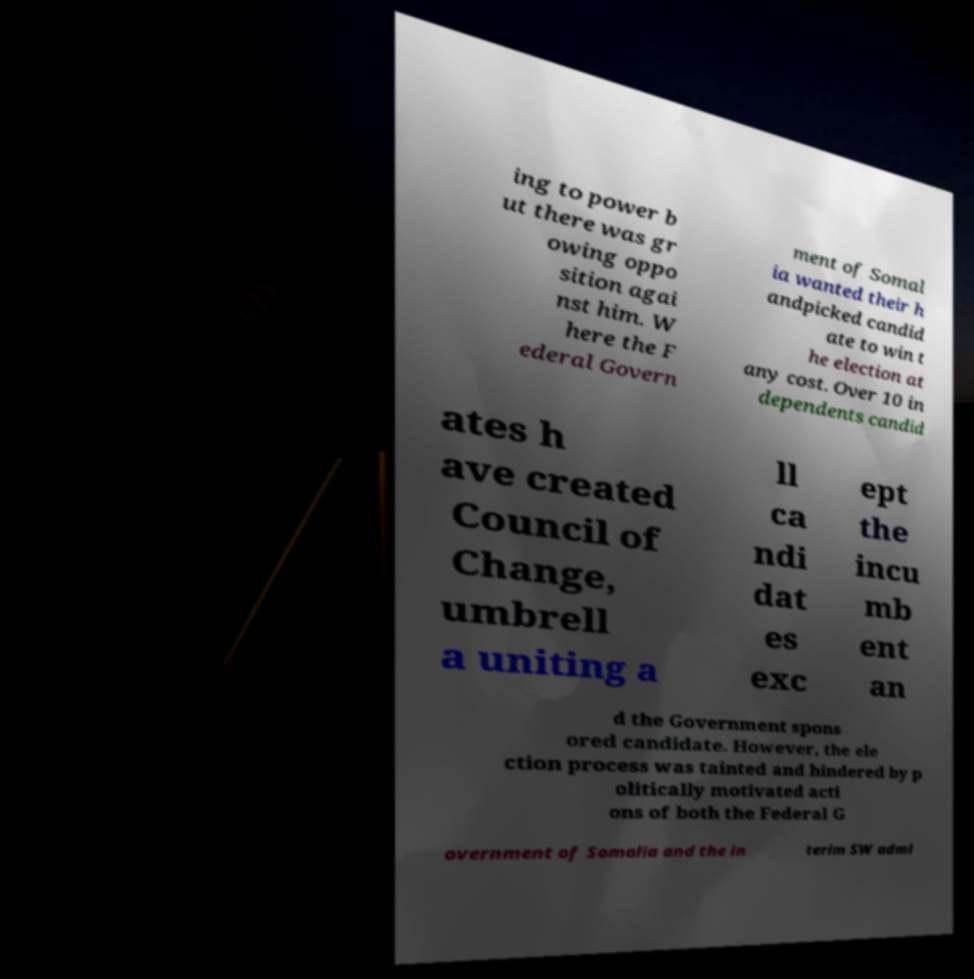Could you extract and type out the text from this image? ing to power b ut there was gr owing oppo sition agai nst him. W here the F ederal Govern ment of Somal ia wanted their h andpicked candid ate to win t he election at any cost. Over 10 in dependents candid ates h ave created Council of Change, umbrell a uniting a ll ca ndi dat es exc ept the incu mb ent an d the Government spons ored candidate. However, the ele ction process was tainted and hindered by p olitically motivated acti ons of both the Federal G overnment of Somalia and the in terim SW admi 